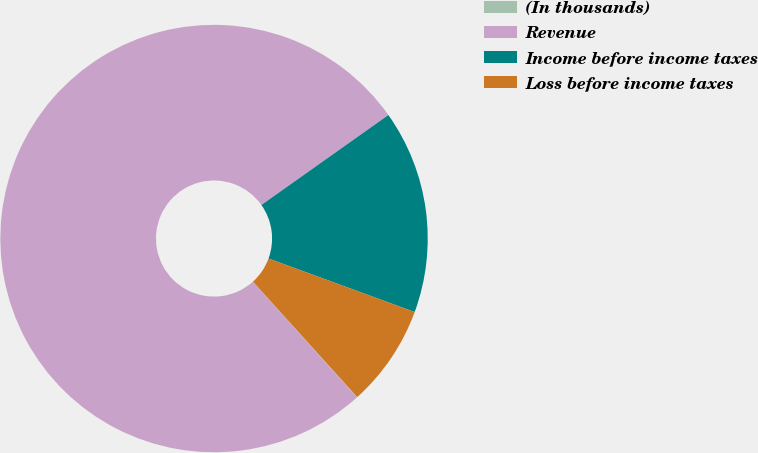Convert chart to OTSL. <chart><loc_0><loc_0><loc_500><loc_500><pie_chart><fcel>(In thousands)<fcel>Revenue<fcel>Income before income taxes<fcel>Loss before income taxes<nl><fcel>0.04%<fcel>76.85%<fcel>15.4%<fcel>7.72%<nl></chart> 